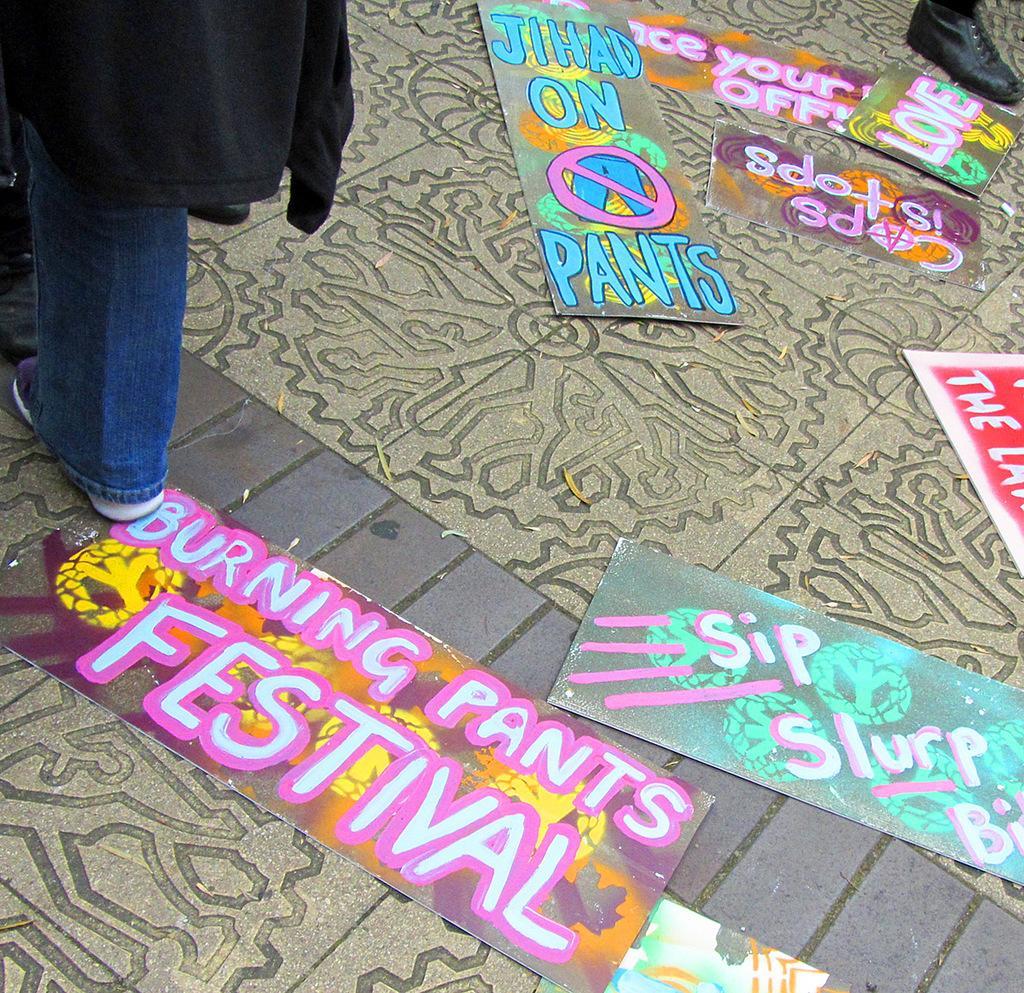Please provide a concise description of this image. In this image I can see there are painted papers on the floor, on the left side there is a woman. 